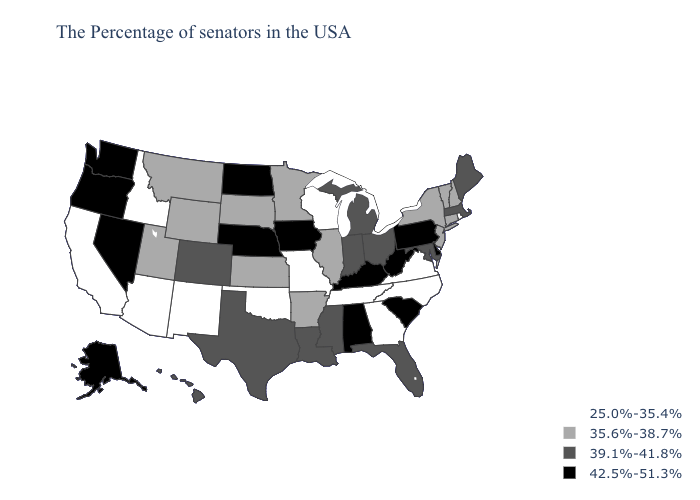Does Missouri have a lower value than Nebraska?
Keep it brief. Yes. Name the states that have a value in the range 42.5%-51.3%?
Write a very short answer. Delaware, Pennsylvania, South Carolina, West Virginia, Kentucky, Alabama, Iowa, Nebraska, North Dakota, Nevada, Washington, Oregon, Alaska. Does South Carolina have the lowest value in the South?
Write a very short answer. No. Name the states that have a value in the range 25.0%-35.4%?
Answer briefly. Rhode Island, Virginia, North Carolina, Georgia, Tennessee, Wisconsin, Missouri, Oklahoma, New Mexico, Arizona, Idaho, California. Name the states that have a value in the range 39.1%-41.8%?
Be succinct. Maine, Massachusetts, Maryland, Ohio, Florida, Michigan, Indiana, Mississippi, Louisiana, Texas, Colorado, Hawaii. Does Iowa have the highest value in the USA?
Give a very brief answer. Yes. What is the lowest value in states that border New Mexico?
Concise answer only. 25.0%-35.4%. What is the value of Utah?
Keep it brief. 35.6%-38.7%. Is the legend a continuous bar?
Quick response, please. No. Name the states that have a value in the range 35.6%-38.7%?
Answer briefly. New Hampshire, Vermont, Connecticut, New York, New Jersey, Illinois, Arkansas, Minnesota, Kansas, South Dakota, Wyoming, Utah, Montana. Does the map have missing data?
Give a very brief answer. No. What is the lowest value in the South?
Answer briefly. 25.0%-35.4%. What is the value of New York?
Answer briefly. 35.6%-38.7%. What is the highest value in the MidWest ?
Write a very short answer. 42.5%-51.3%. Name the states that have a value in the range 39.1%-41.8%?
Keep it brief. Maine, Massachusetts, Maryland, Ohio, Florida, Michigan, Indiana, Mississippi, Louisiana, Texas, Colorado, Hawaii. 